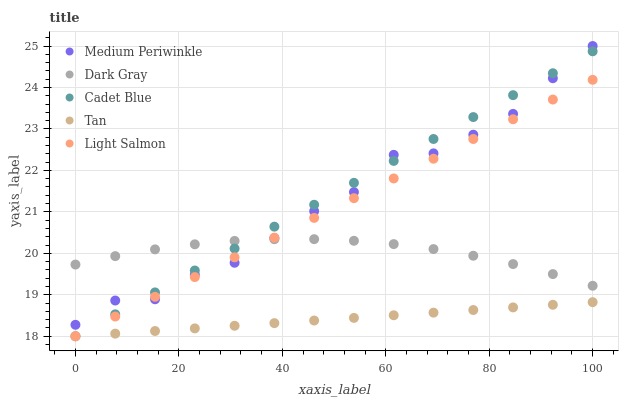Does Tan have the minimum area under the curve?
Answer yes or no. Yes. Does Cadet Blue have the maximum area under the curve?
Answer yes or no. Yes. Does Cadet Blue have the minimum area under the curve?
Answer yes or no. No. Does Tan have the maximum area under the curve?
Answer yes or no. No. Is Cadet Blue the smoothest?
Answer yes or no. Yes. Is Medium Periwinkle the roughest?
Answer yes or no. Yes. Is Tan the smoothest?
Answer yes or no. No. Is Tan the roughest?
Answer yes or no. No. Does Tan have the lowest value?
Answer yes or no. Yes. Does Medium Periwinkle have the lowest value?
Answer yes or no. No. Does Medium Periwinkle have the highest value?
Answer yes or no. Yes. Does Cadet Blue have the highest value?
Answer yes or no. No. Is Tan less than Medium Periwinkle?
Answer yes or no. Yes. Is Medium Periwinkle greater than Tan?
Answer yes or no. Yes. Does Tan intersect Light Salmon?
Answer yes or no. Yes. Is Tan less than Light Salmon?
Answer yes or no. No. Is Tan greater than Light Salmon?
Answer yes or no. No. Does Tan intersect Medium Periwinkle?
Answer yes or no. No. 